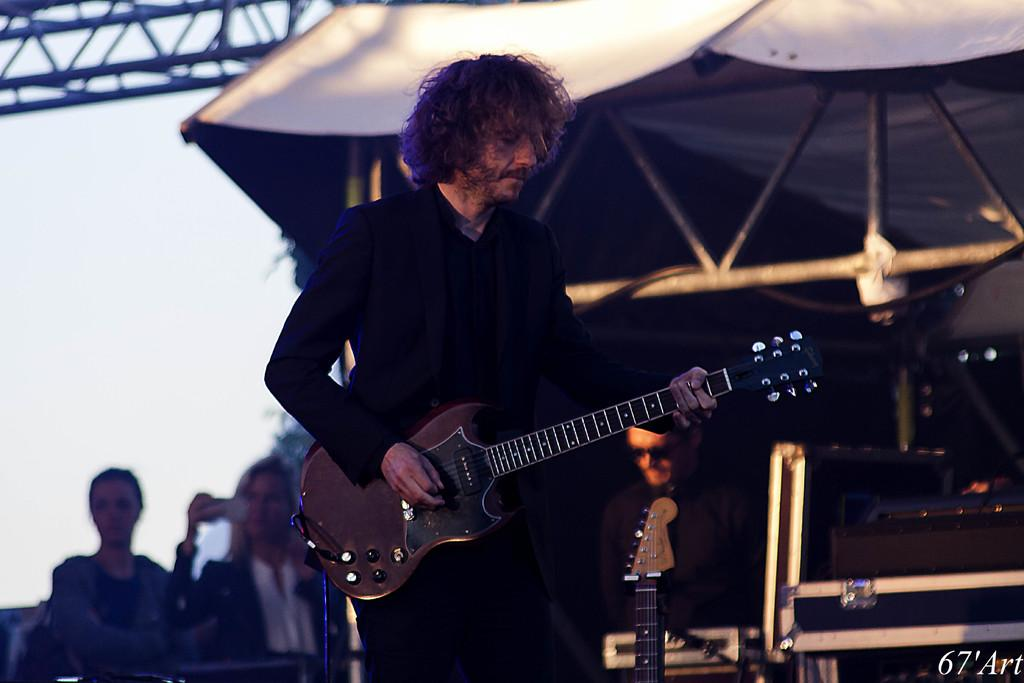Who is the main subject in the image? There is a man in the image. What is the man wearing? The man is wearing a black suit. What is the man holding in the image? The man is holding a guitar. What is the man doing with the guitar? The man is playing the guitar. What other musical instruments can be seen in the image? There are other musical instruments in the image. What time is displayed on the clock in the image? There is no clock present in the image. How does the man use the dock to play the guitar in the image? There is no dock present in the image, and the man is not using any dock to play the guitar. 